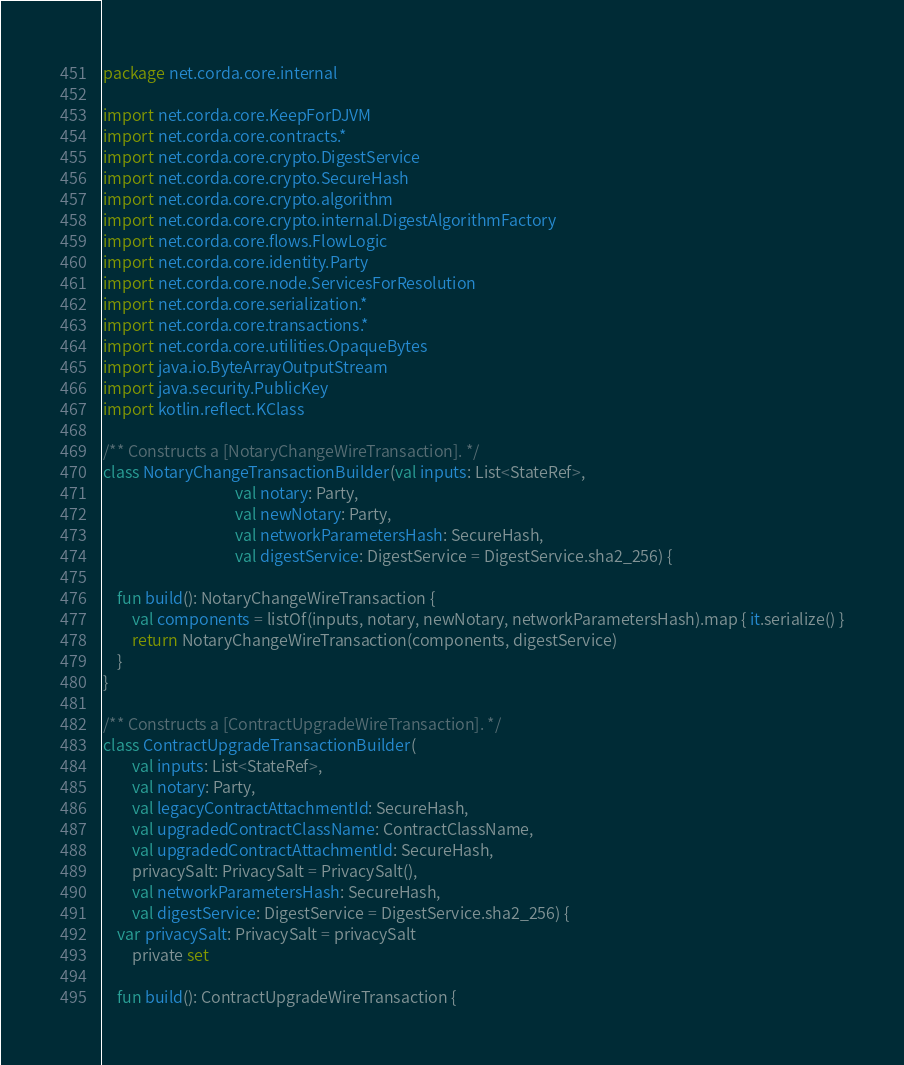<code> <loc_0><loc_0><loc_500><loc_500><_Kotlin_>package net.corda.core.internal

import net.corda.core.KeepForDJVM
import net.corda.core.contracts.*
import net.corda.core.crypto.DigestService
import net.corda.core.crypto.SecureHash
import net.corda.core.crypto.algorithm
import net.corda.core.crypto.internal.DigestAlgorithmFactory
import net.corda.core.flows.FlowLogic
import net.corda.core.identity.Party
import net.corda.core.node.ServicesForResolution
import net.corda.core.serialization.*
import net.corda.core.transactions.*
import net.corda.core.utilities.OpaqueBytes
import java.io.ByteArrayOutputStream
import java.security.PublicKey
import kotlin.reflect.KClass

/** Constructs a [NotaryChangeWireTransaction]. */
class NotaryChangeTransactionBuilder(val inputs: List<StateRef>,
                                     val notary: Party,
                                     val newNotary: Party,
                                     val networkParametersHash: SecureHash,
                                     val digestService: DigestService = DigestService.sha2_256) {

    fun build(): NotaryChangeWireTransaction {
        val components = listOf(inputs, notary, newNotary, networkParametersHash).map { it.serialize() }
        return NotaryChangeWireTransaction(components, digestService)
    }
}

/** Constructs a [ContractUpgradeWireTransaction]. */
class ContractUpgradeTransactionBuilder(
        val inputs: List<StateRef>,
        val notary: Party,
        val legacyContractAttachmentId: SecureHash,
        val upgradedContractClassName: ContractClassName,
        val upgradedContractAttachmentId: SecureHash,
        privacySalt: PrivacySalt = PrivacySalt(),
        val networkParametersHash: SecureHash,
        val digestService: DigestService = DigestService.sha2_256) {
    var privacySalt: PrivacySalt = privacySalt
        private set

    fun build(): ContractUpgradeWireTransaction {</code> 